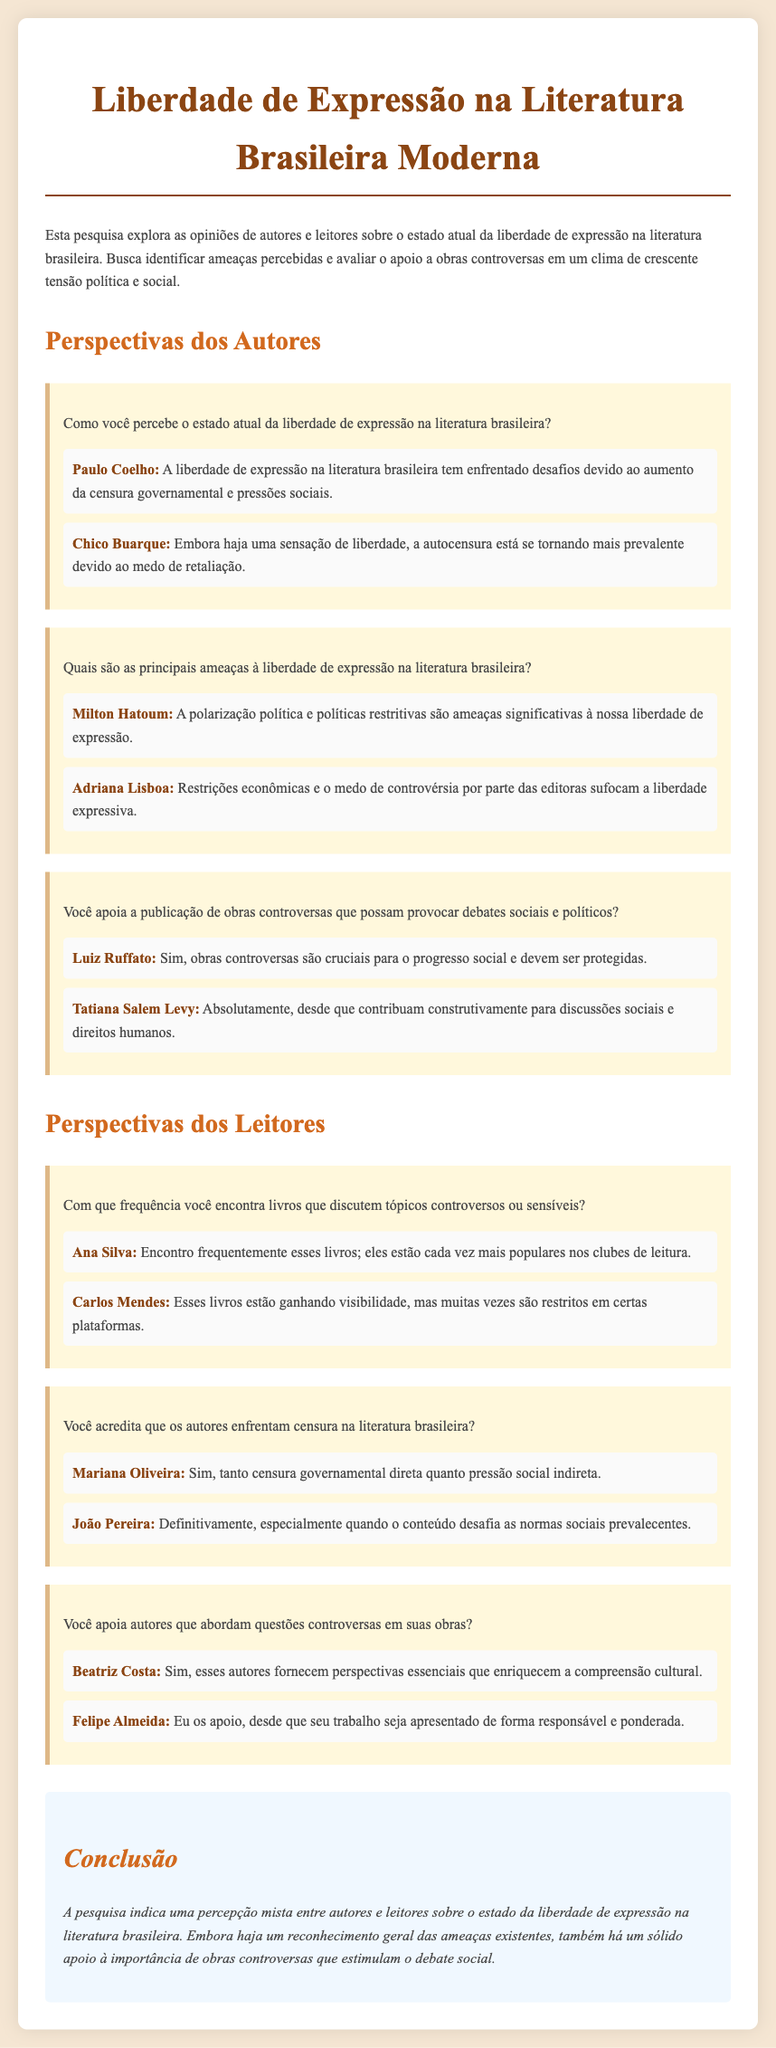What is the title of the document? The title is explicitly stated in the header of the document as "Liberdade de Expressão na Literatura Brasileira Moderna."
Answer: Liberdade de Expressão na Literatura Brasileira Moderna Who is the author that perceives challenges due to censorship? The document mentions Paulo Coelho as perceiving challenges in freedom of expression related to censorship.
Answer: Paulo Coelho What are the two main threats to freedom of expression mentioned by authors? Milton Hatoum and Adriana Lisboa mention threats such as polarization and economic restrictions.
Answer: Polarização e restrições econômicas Do readers believe that authors face censorship in Brazilian literature? The reader Mariana Oliveira expresses agreement that authors face censorship.
Answer: Sim How do readers feel about supporting authors who tackle controversial issues? Beatriz Costa affirms that such authors provide essential perspectives, indicating support.
Answer: Sim 